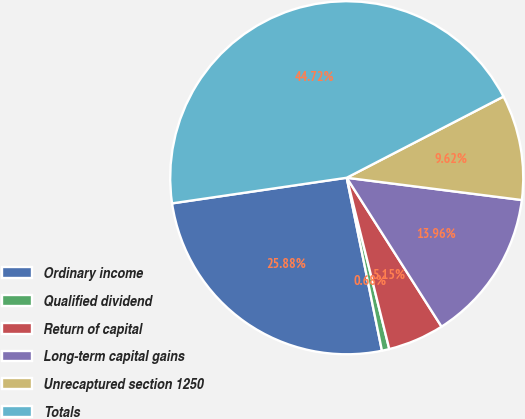Convert chart to OTSL. <chart><loc_0><loc_0><loc_500><loc_500><pie_chart><fcel>Ordinary income<fcel>Qualified dividend<fcel>Return of capital<fcel>Long-term capital gains<fcel>Unrecaptured section 1250<fcel>Totals<nl><fcel>25.88%<fcel>0.68%<fcel>5.15%<fcel>13.96%<fcel>9.62%<fcel>44.72%<nl></chart> 